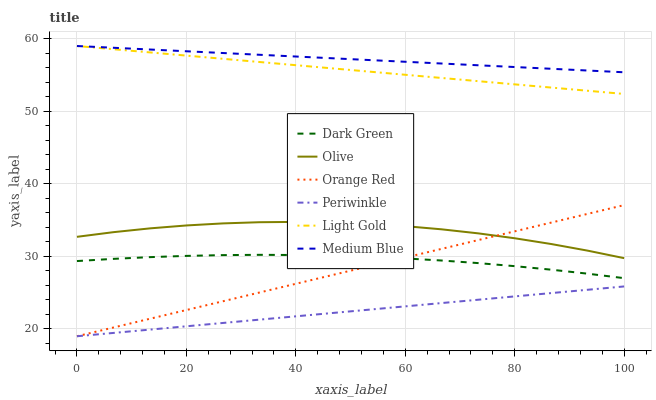Does Olive have the minimum area under the curve?
Answer yes or no. No. Does Olive have the maximum area under the curve?
Answer yes or no. No. Is Olive the smoothest?
Answer yes or no. No. Is Periwinkle the roughest?
Answer yes or no. No. Does Olive have the lowest value?
Answer yes or no. No. Does Olive have the highest value?
Answer yes or no. No. Is Olive less than Medium Blue?
Answer yes or no. Yes. Is Medium Blue greater than Periwinkle?
Answer yes or no. Yes. Does Olive intersect Medium Blue?
Answer yes or no. No. 